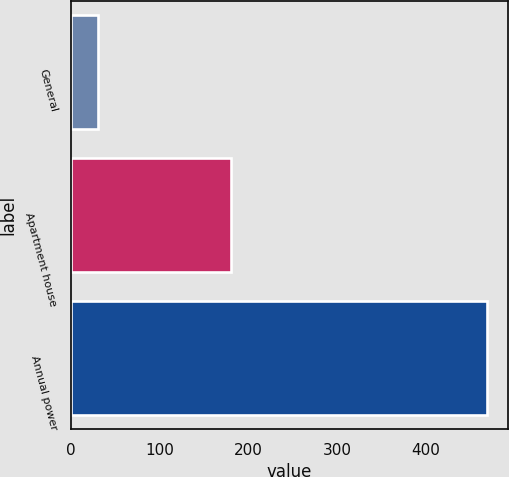Convert chart to OTSL. <chart><loc_0><loc_0><loc_500><loc_500><bar_chart><fcel>General<fcel>Apartment house<fcel>Annual power<nl><fcel>30<fcel>180<fcel>469<nl></chart> 